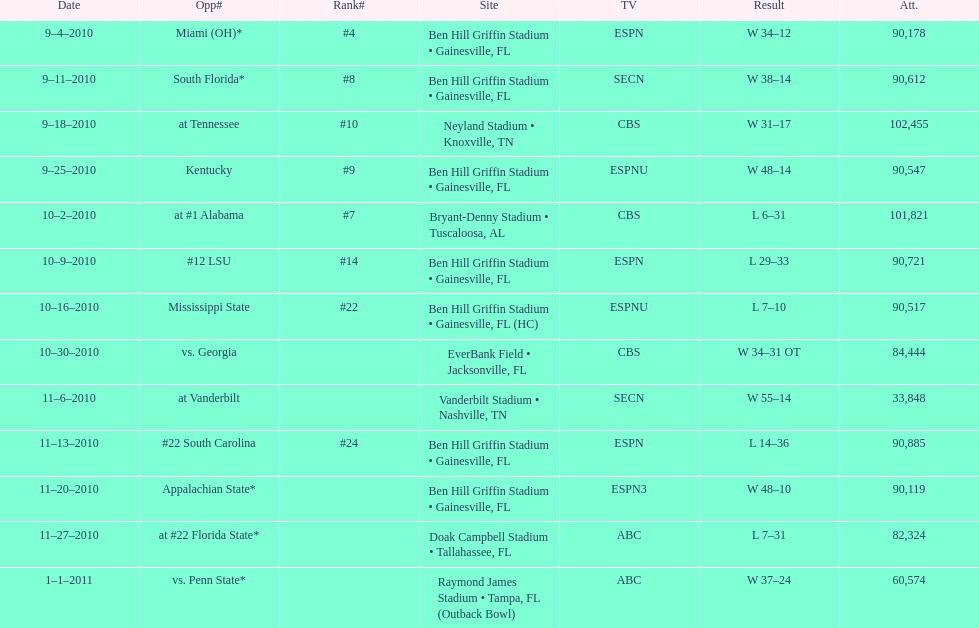What tv network showed the largest number of games during the 2010/2011 season? ESPN. 